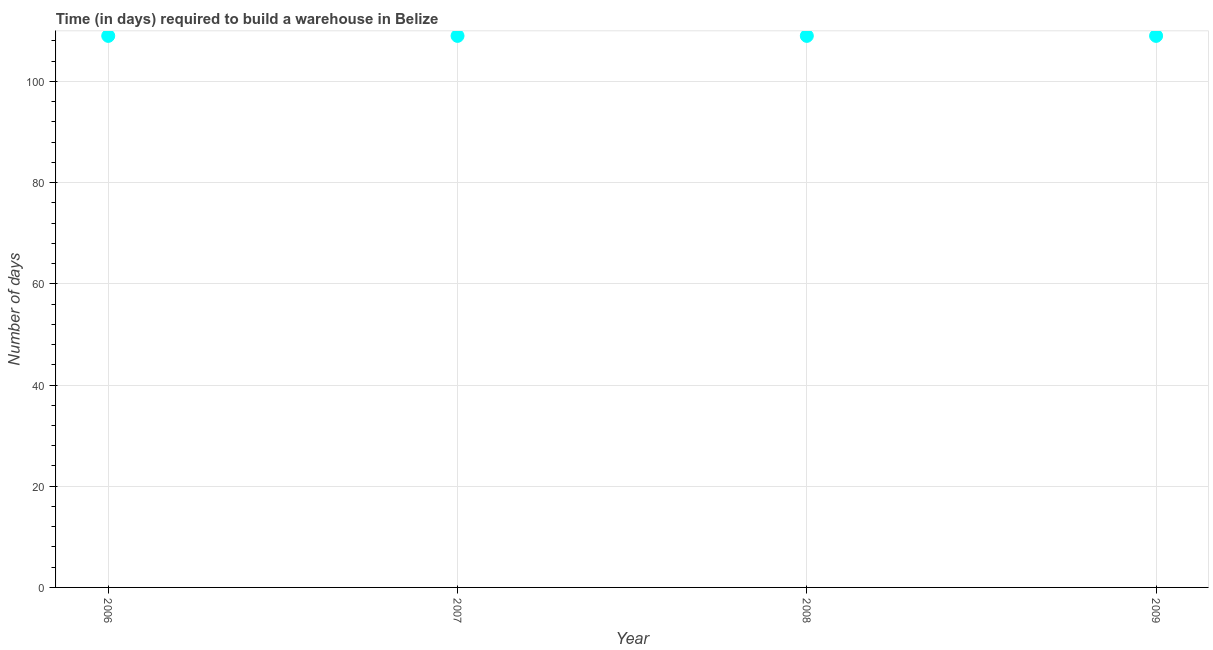What is the time required to build a warehouse in 2008?
Provide a succinct answer. 109. Across all years, what is the maximum time required to build a warehouse?
Offer a terse response. 109. Across all years, what is the minimum time required to build a warehouse?
Provide a short and direct response. 109. In which year was the time required to build a warehouse minimum?
Provide a short and direct response. 2006. What is the sum of the time required to build a warehouse?
Offer a very short reply. 436. What is the difference between the time required to build a warehouse in 2006 and 2009?
Provide a succinct answer. 0. What is the average time required to build a warehouse per year?
Make the answer very short. 109. What is the median time required to build a warehouse?
Offer a very short reply. 109. In how many years, is the time required to build a warehouse greater than 24 days?
Give a very brief answer. 4. What is the difference between the highest and the lowest time required to build a warehouse?
Your answer should be very brief. 0. In how many years, is the time required to build a warehouse greater than the average time required to build a warehouse taken over all years?
Provide a short and direct response. 0. What is the difference between two consecutive major ticks on the Y-axis?
Offer a very short reply. 20. What is the title of the graph?
Keep it short and to the point. Time (in days) required to build a warehouse in Belize. What is the label or title of the Y-axis?
Your answer should be very brief. Number of days. What is the Number of days in 2006?
Keep it short and to the point. 109. What is the Number of days in 2007?
Ensure brevity in your answer.  109. What is the Number of days in 2008?
Provide a short and direct response. 109. What is the Number of days in 2009?
Provide a short and direct response. 109. What is the difference between the Number of days in 2008 and 2009?
Your response must be concise. 0. What is the ratio of the Number of days in 2006 to that in 2007?
Offer a very short reply. 1. What is the ratio of the Number of days in 2006 to that in 2008?
Your answer should be very brief. 1. What is the ratio of the Number of days in 2006 to that in 2009?
Ensure brevity in your answer.  1. 